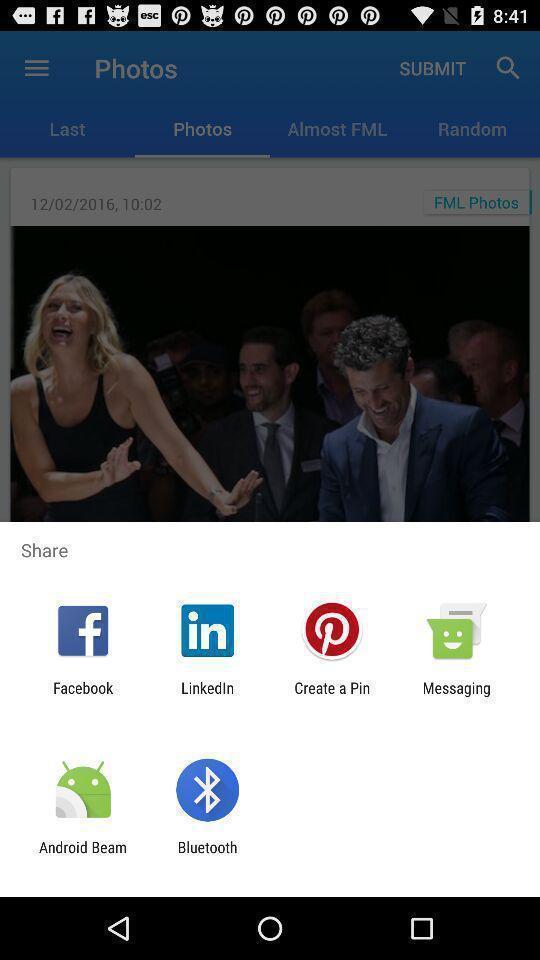Describe this image in words. Pop-up displaying various apps to share data. 